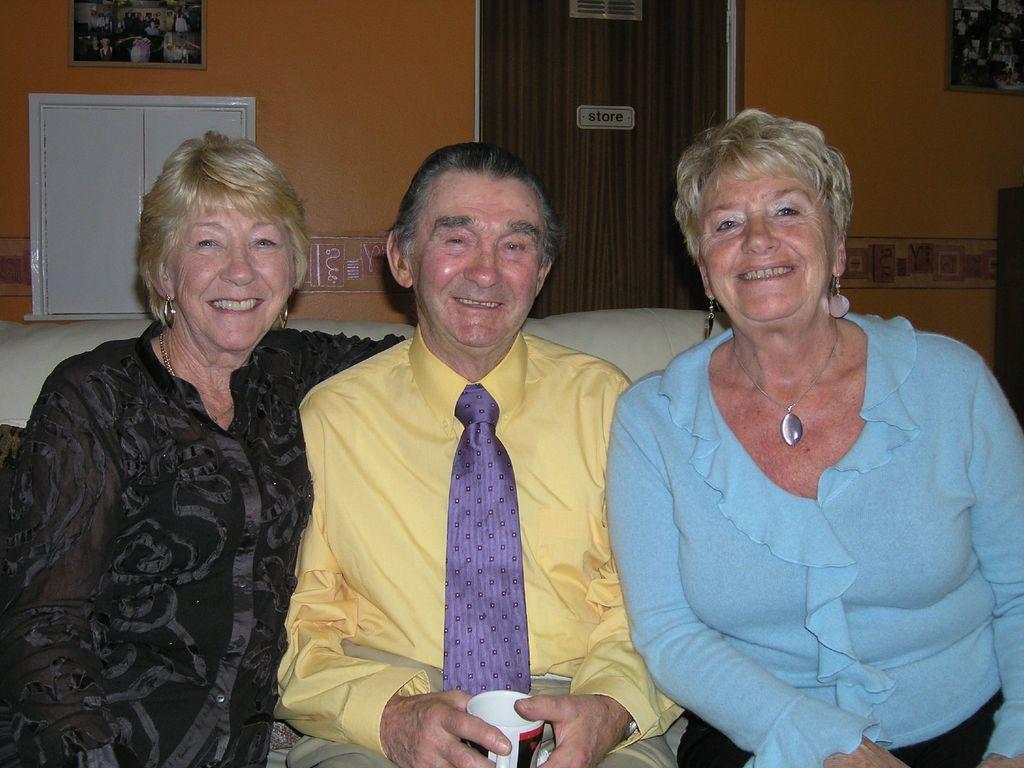Describe this image in one or two sentences. In this image, we can see three persons are sitting on the couch. They are watching and smiling. Here a man is holding a cup. Background we can see wall, door, cupboard and photo frames. 